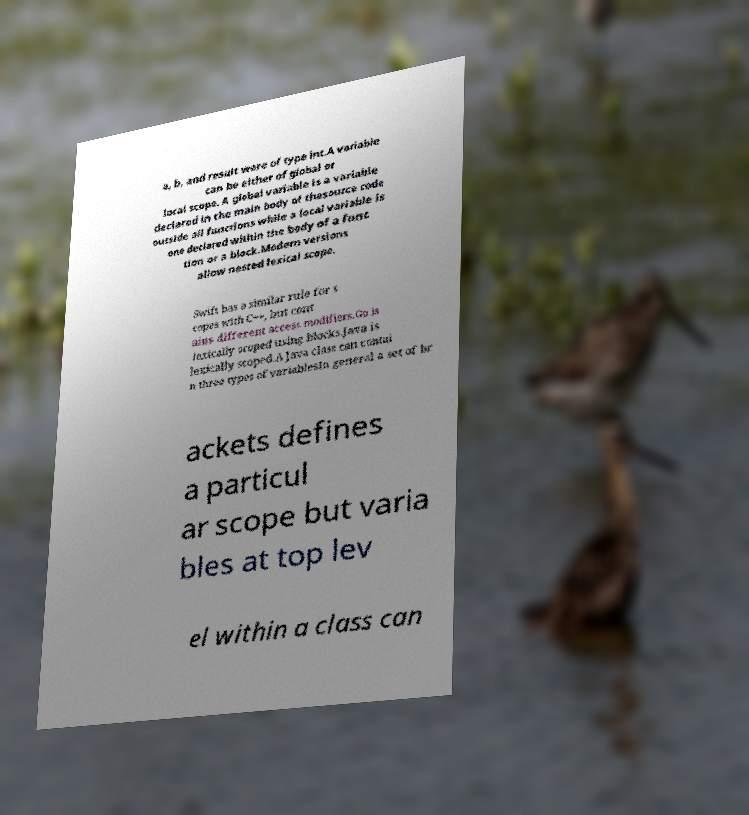Can you accurately transcribe the text from the provided image for me? a, b, and result were of type int.A variable can be either of global or local scope. A global variable is a variable declared in the main body of thesource code outside all functions while a local variable is one declared within the body of a func tion or a block.Modern versions allow nested lexical scope. Swift has a similar rule for s copes with C++, but cont ains different access modifiers.Go is lexically scoped using blocks.Java is lexically scoped.A Java class can contai n three types of variablesIn general a set of br ackets defines a particul ar scope but varia bles at top lev el within a class can 